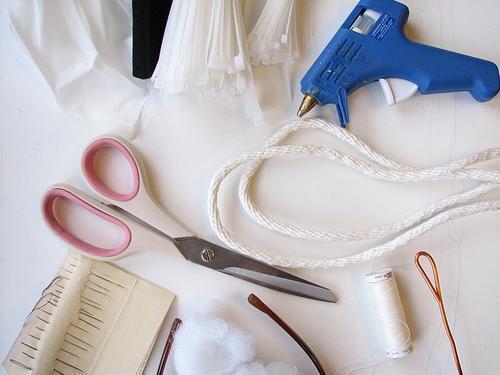How many people are holding scissors?
Give a very brief answer. 0. 